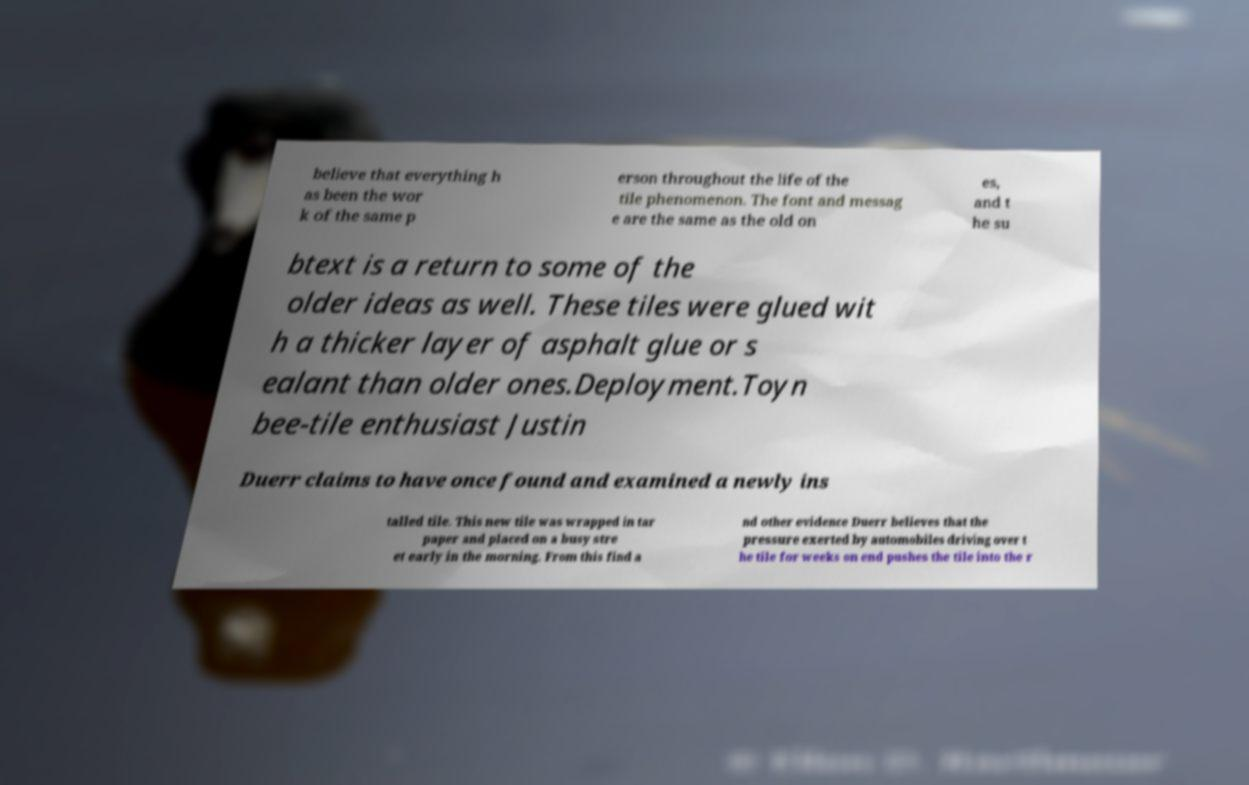Please read and relay the text visible in this image. What does it say? believe that everything h as been the wor k of the same p erson throughout the life of the tile phenomenon. The font and messag e are the same as the old on es, and t he su btext is a return to some of the older ideas as well. These tiles were glued wit h a thicker layer of asphalt glue or s ealant than older ones.Deployment.Toyn bee-tile enthusiast Justin Duerr claims to have once found and examined a newly ins talled tile. This new tile was wrapped in tar paper and placed on a busy stre et early in the morning. From this find a nd other evidence Duerr believes that the pressure exerted by automobiles driving over t he tile for weeks on end pushes the tile into the r 